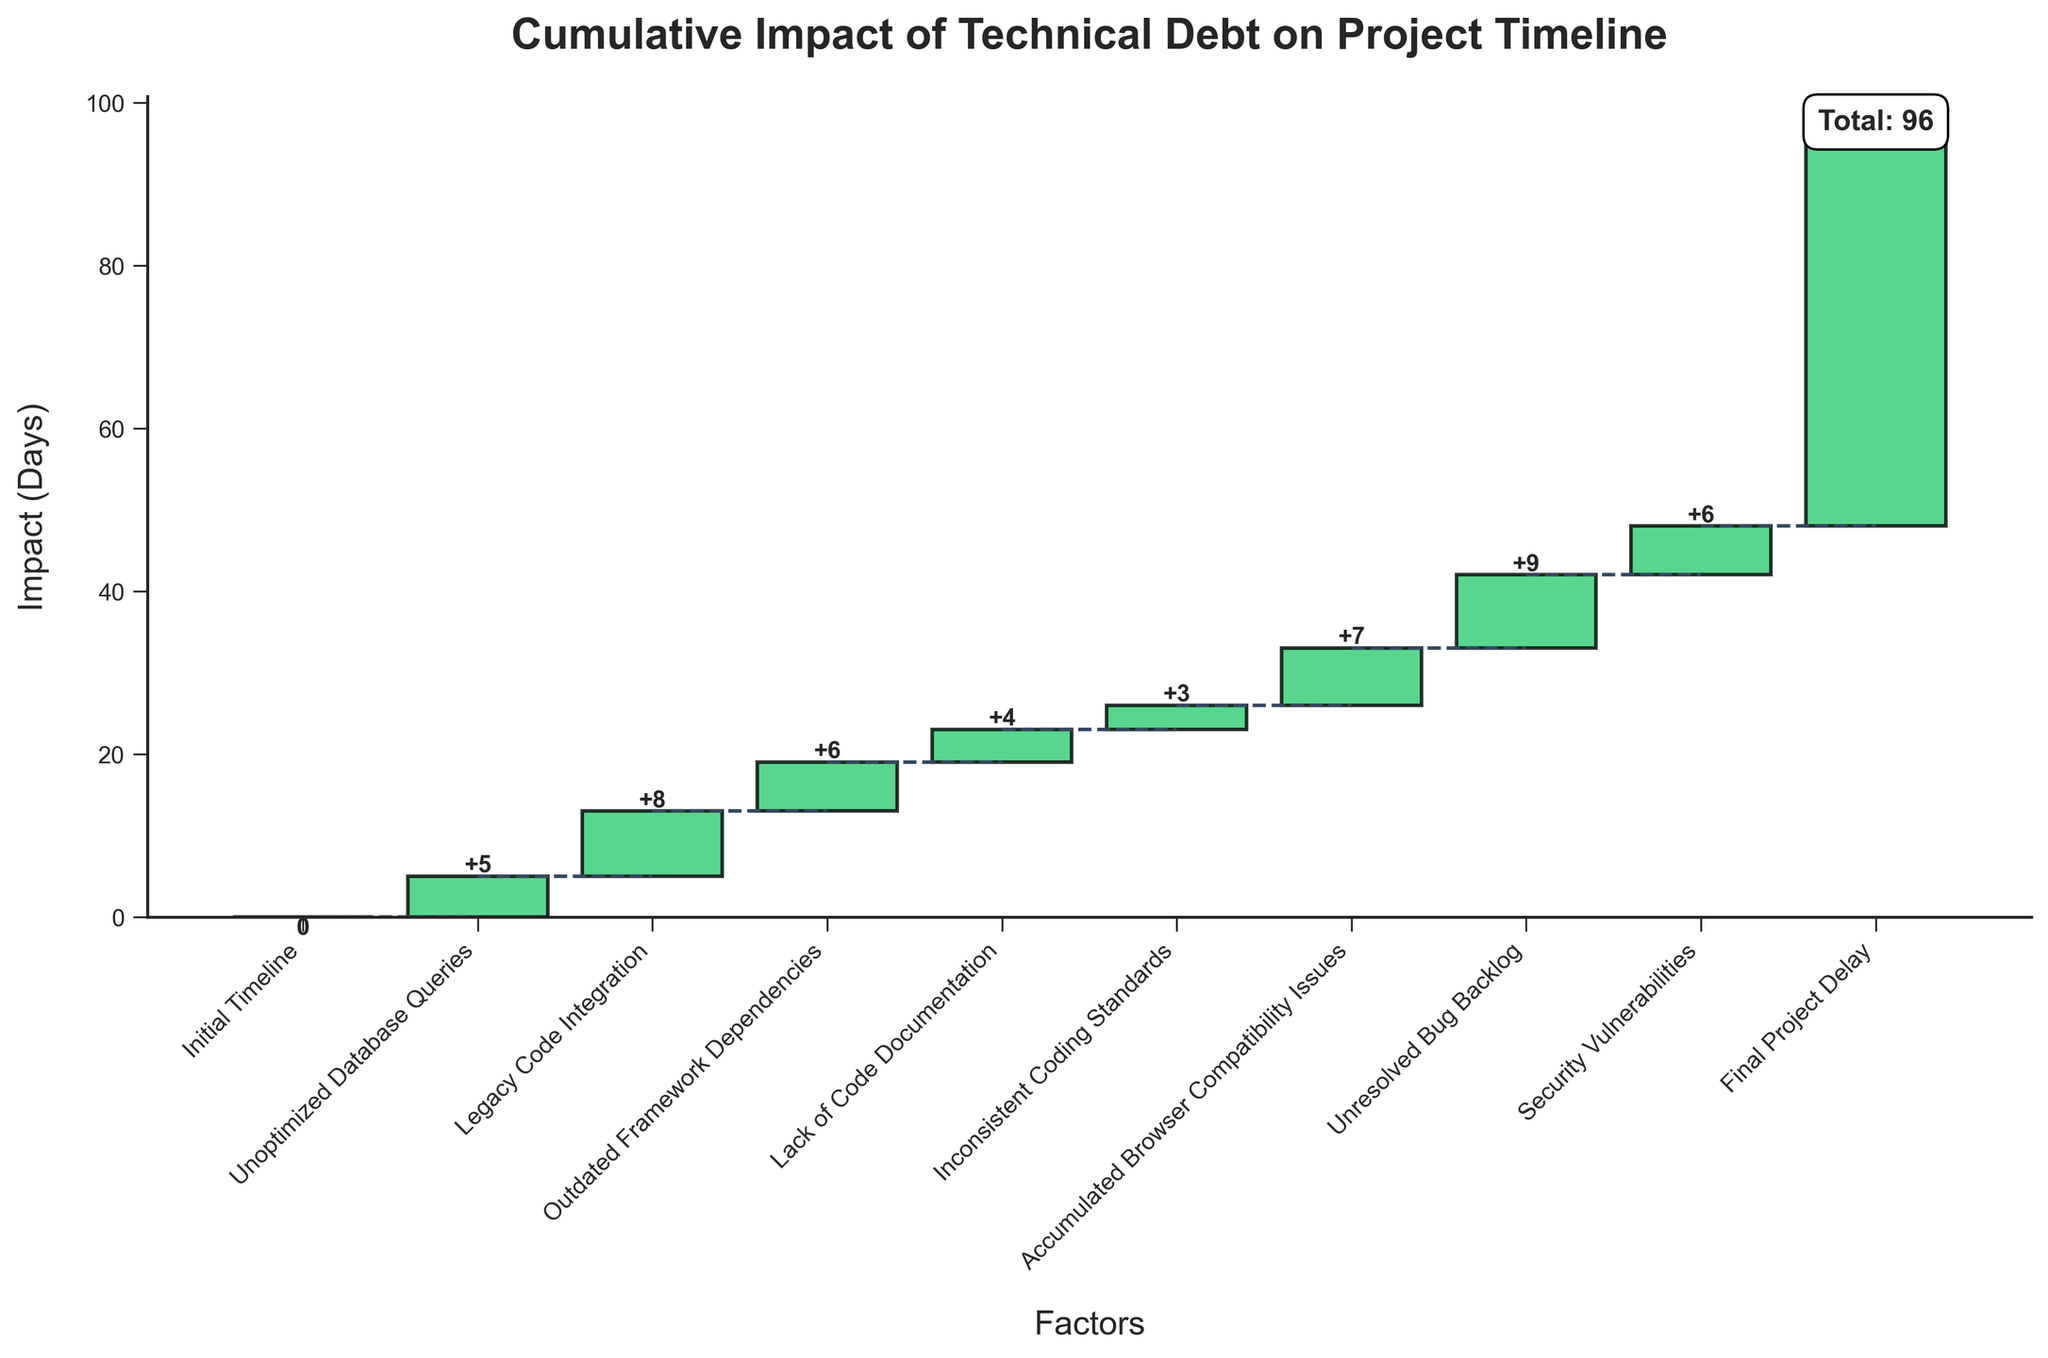What's the title of the chart? The title of the chart is displayed at the top of the figure. It reads "Cumulative Impact of Technical Debt on Project Timeline".
Answer: Cumulative Impact of Technical Debt on Project Timeline How many categories are featured in the chart? By looking at the x-axis, we can count the number of ticks or labels representing different categories. There are 9 categories plus the initial and final points, making a total of 10.
Answer: 10 What is the cumulative impact value for "Legacy Code Integration"? The cumulative impact for "Legacy Code Integration" can be found by looking at the top of the bar for this category. The bar starts at 5 (end of the previous category, "Unoptimized Database Queries") and ends at 13 (5+8), so the cumulative impact is 13 days.
Answer: 13 Which category has the smallest individual impact? By comparing the heights of all bars, we can see that "Inconsistent Coding Standards" has the smallest value, which is 3 days.
Answer: Inconsistent Coding Standards What is the cumulative impact right before the "Final Project Delay"? The cumulative impact before the "Final Project Delay" is at the top of the bar labeled "Security Vulnerabilities". Adding up all previous values, the cumulative impact is 48 - 6 = 42 days.
Answer: 42 Which category contributes the most to the final delay? By comparing the heights of the individual bars, "Unresolved Bug Backlog" has the highest value of 9 days.
Answer: Unresolved Bug Backlog What's the difference in impact between "Unoptimized Database Queries" and "Accumulated Browser Compatibility Issues"? "Unoptimized Database Queries" has an impact of 5 days and "Accumulated Browser Compatibility Issues" has an impact of 7 days. The difference is 7 - 5 = 2 days.
Answer: 2 How does the final project delay compare to the sum of all previous impacts? The final project delay value is displayed on the chart as 48 days. Adding up all prior impacts, we get 5 + 8 + 6 + 4 + 3 + 7 + 9 + 6 = 48 days, which matches the final project delay.
Answer: Matches What is the visual indicator used to represent categories with positive impacts? Categories with positive impacts are represented using green color bars. This can be visually confirmed by looking at the green bars in the chart.
Answer: Green color bars What is the total impact caused by "Outdated Framework Dependencies" and "Lack of Code Documentation"? The impact of "Outdated Framework Dependencies" is 6 days and for "Lack of Code Documentation" is 4 days. Adding them together gives 6 + 4 = 10 days.
Answer: 10 